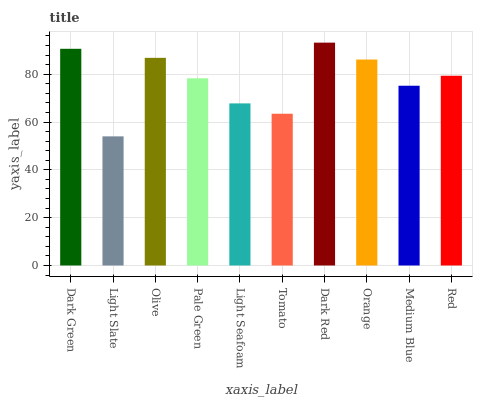Is Light Slate the minimum?
Answer yes or no. Yes. Is Dark Red the maximum?
Answer yes or no. Yes. Is Olive the minimum?
Answer yes or no. No. Is Olive the maximum?
Answer yes or no. No. Is Olive greater than Light Slate?
Answer yes or no. Yes. Is Light Slate less than Olive?
Answer yes or no. Yes. Is Light Slate greater than Olive?
Answer yes or no. No. Is Olive less than Light Slate?
Answer yes or no. No. Is Red the high median?
Answer yes or no. Yes. Is Pale Green the low median?
Answer yes or no. Yes. Is Tomato the high median?
Answer yes or no. No. Is Medium Blue the low median?
Answer yes or no. No. 